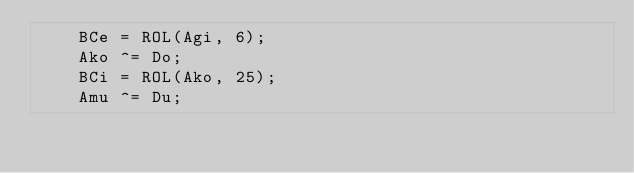<code> <loc_0><loc_0><loc_500><loc_500><_C_>		BCe = ROL(Agi, 6);
		Ako ^= Do;
		BCi = ROL(Ako, 25);
		Amu ^= Du;</code> 